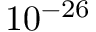Convert formula to latex. <formula><loc_0><loc_0><loc_500><loc_500>1 0 ^ { - 2 6 }</formula> 